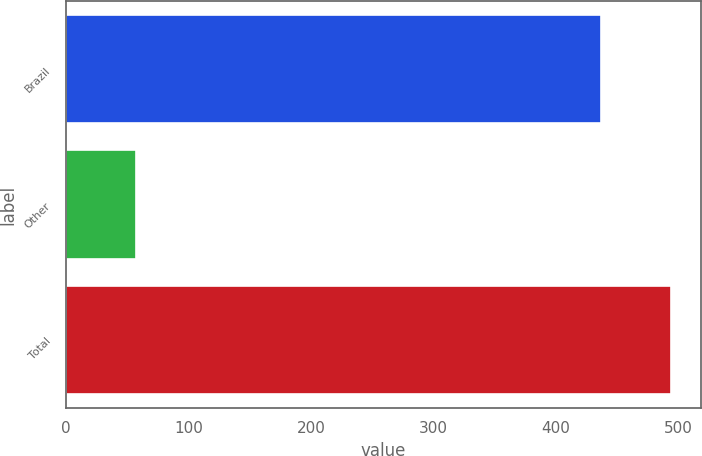<chart> <loc_0><loc_0><loc_500><loc_500><bar_chart><fcel>Brazil<fcel>Other<fcel>Total<nl><fcel>437<fcel>57<fcel>494<nl></chart> 